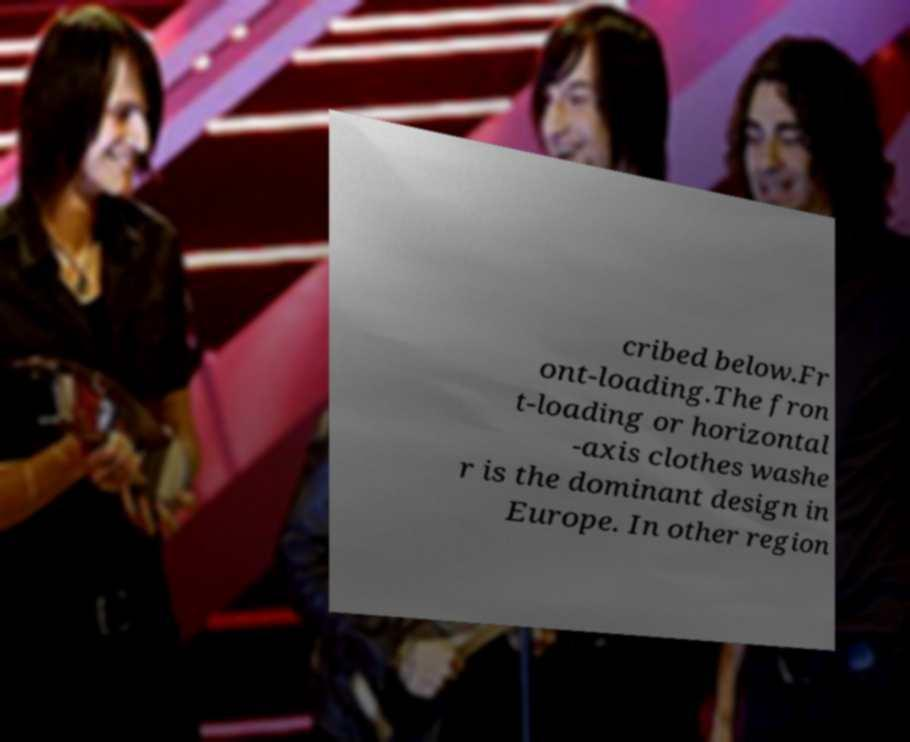Please read and relay the text visible in this image. What does it say? cribed below.Fr ont-loading.The fron t-loading or horizontal -axis clothes washe r is the dominant design in Europe. In other region 